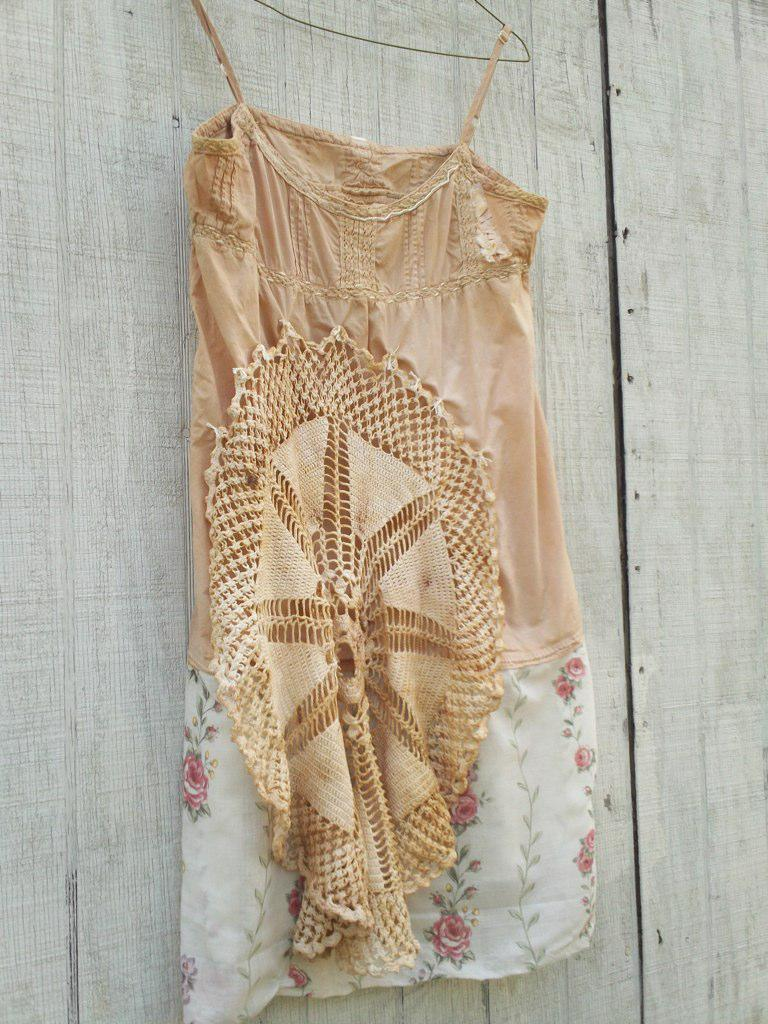What is hanging on the cloth hanger in the image? There is a dress on a cloth hanger in the image. What can be seen in the background of the image? There is a wall in the background of the image. What type of pen is visible in the pocket of the dress in the image? There is no pen or pocket visible in the image; it only shows a dress on a cloth hanger and a wall in the background. 